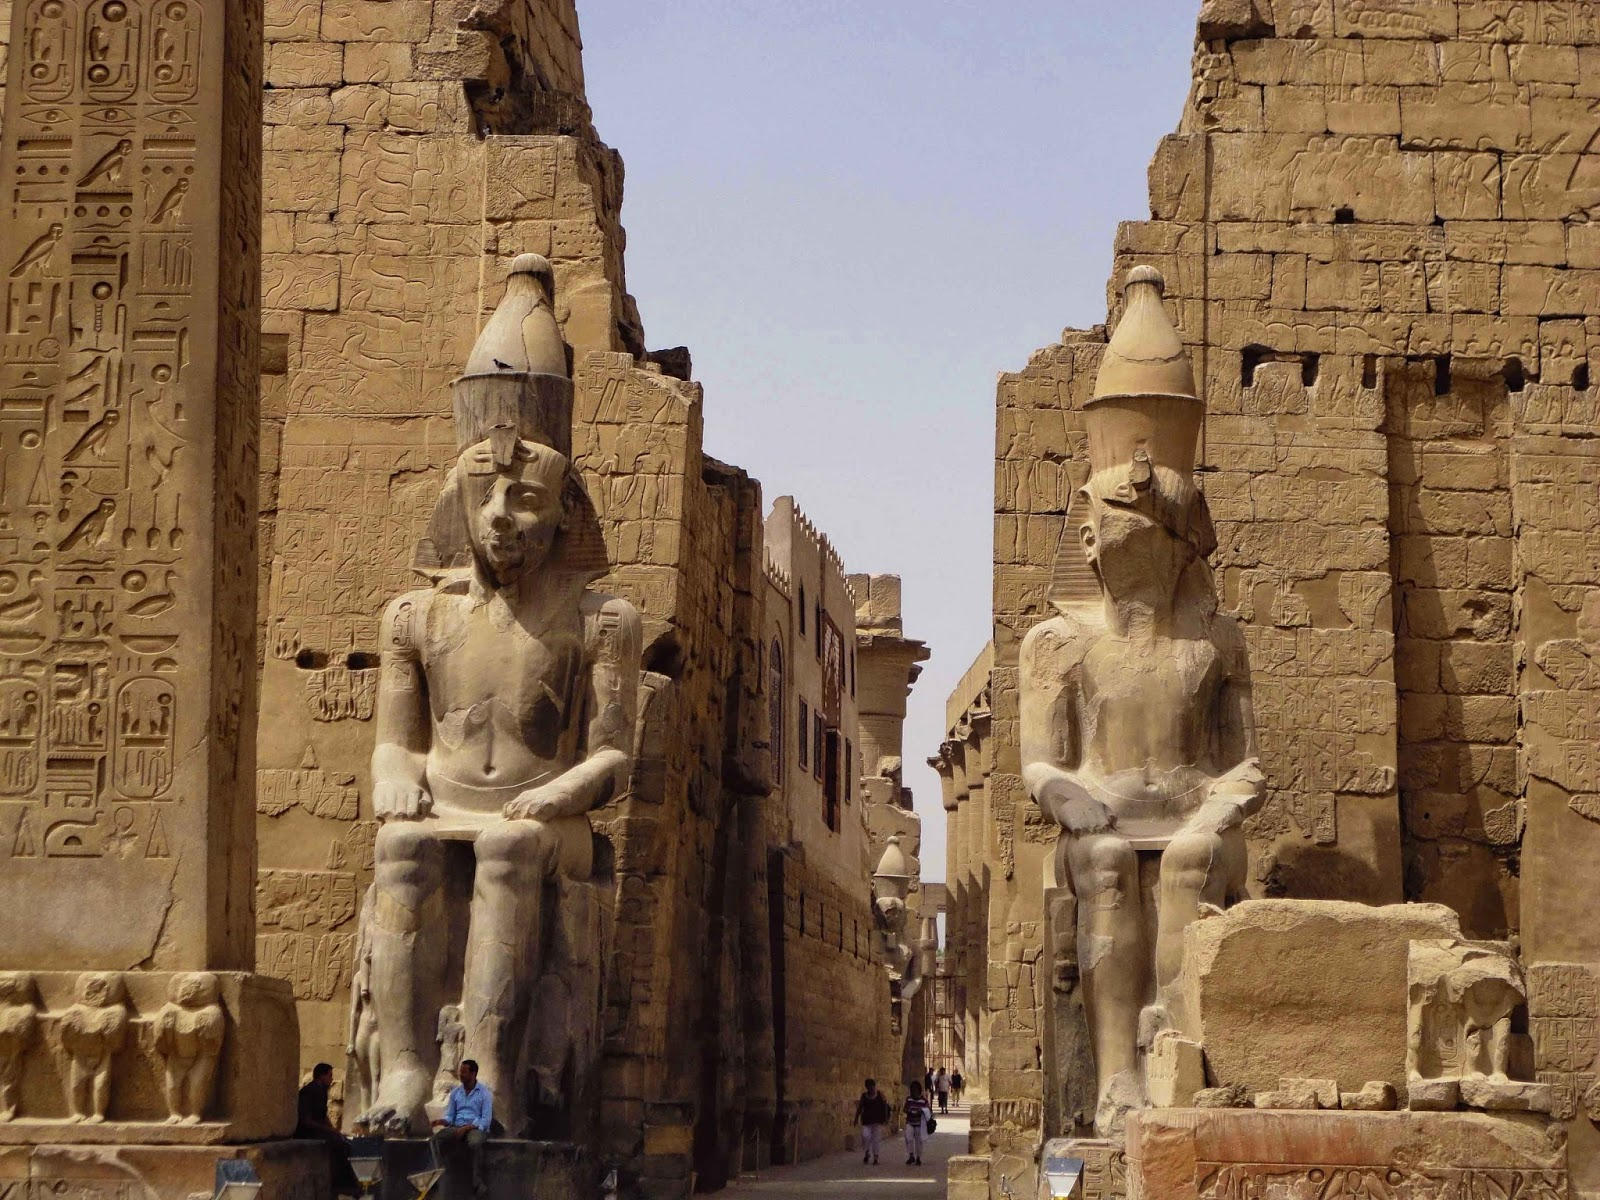Describe a fantastical event that could happen here. In the stillness of a moonlit night, the Luxor Temple awakens. The statues shimmer and begin to move, stepping down with regal grace. The hieroglyphics on the walls glow softly, telling ancient stories anew. Spirits of past pharaohs and deities emerge, cloaked in ethereal light, as the temple transforms into a grand council. They discuss the fate of the world, sharing wisdom and secrets hidden for millennia. Visitors who witness this extraordinary event find themselves in a dreamlike trance, absorbing knowledge and visions beyond their wildest imaginations. By dawn, the temple returns to its silent state, leaving the fortunate few with memories of a magical night. 